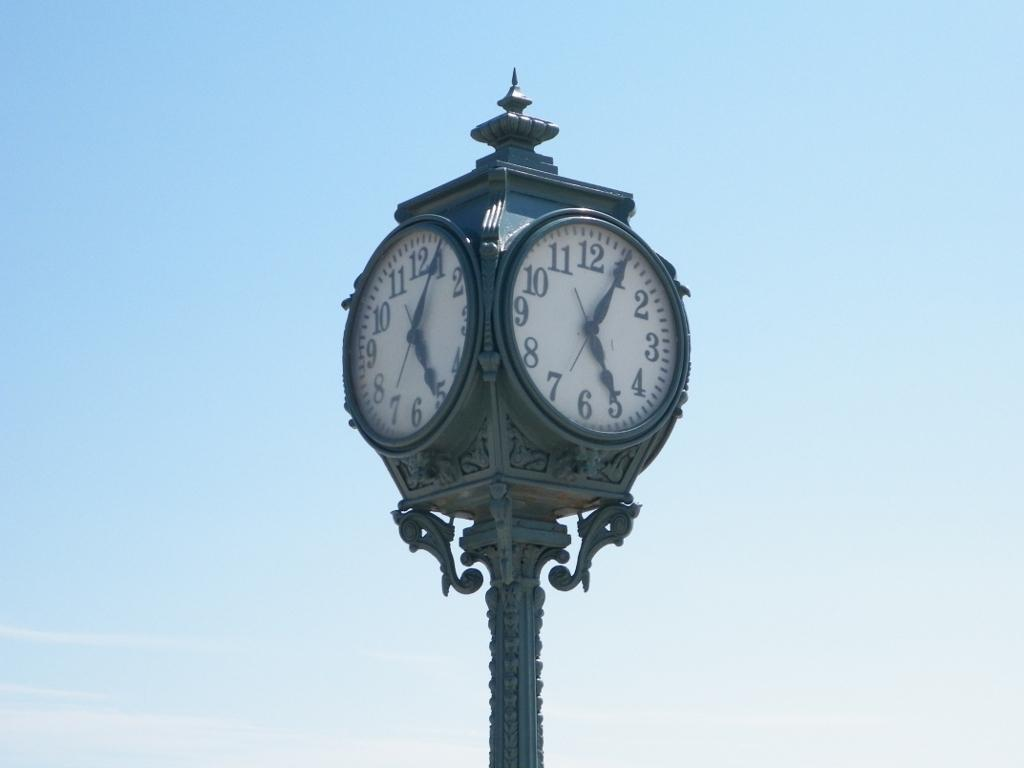<image>
Describe the image concisely. A clock shows the time to be five minutes past five. 